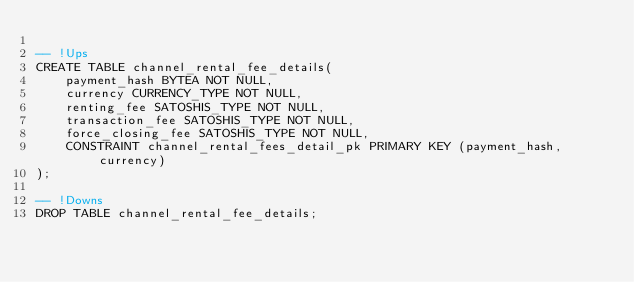Convert code to text. <code><loc_0><loc_0><loc_500><loc_500><_SQL_>
-- !Ups
CREATE TABLE channel_rental_fee_details(
    payment_hash BYTEA NOT NULL,
    currency CURRENCY_TYPE NOT NULL,
    renting_fee SATOSHIS_TYPE NOT NULL,
    transaction_fee SATOSHIS_TYPE NOT NULL,
    force_closing_fee SATOSHIS_TYPE NOT NULL,
    CONSTRAINT channel_rental_fees_detail_pk PRIMARY KEY (payment_hash, currency)
);

-- !Downs
DROP TABLE channel_rental_fee_details;
</code> 